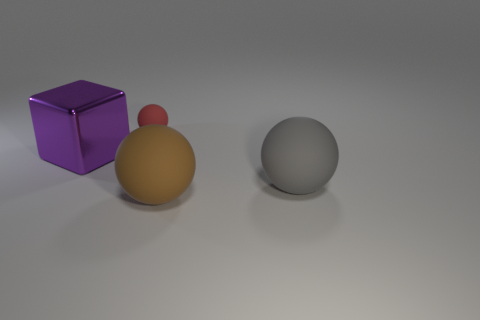What is the gray sphere made of? While I can't determine the exact material composition from a picture, the gray sphere has a matte surface that could suggest it's made of a material such as plastic, ceramic, or stone. 